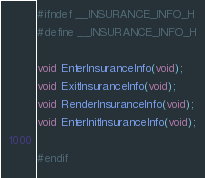Convert code to text. <code><loc_0><loc_0><loc_500><loc_500><_C_>#ifndef __INSURANCE_INFO_H
#define __INSURANCE_INFO_H

void EnterInsuranceInfo(void);
void ExitInsuranceInfo(void);
void RenderInsuranceInfo(void);
void EnterInitInsuranceInfo(void);

#endif
</code> 